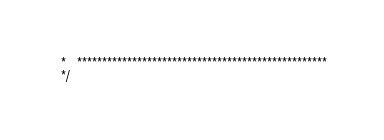<code> <loc_0><loc_0><loc_500><loc_500><_C_> *   **************************************************
 */
</code> 